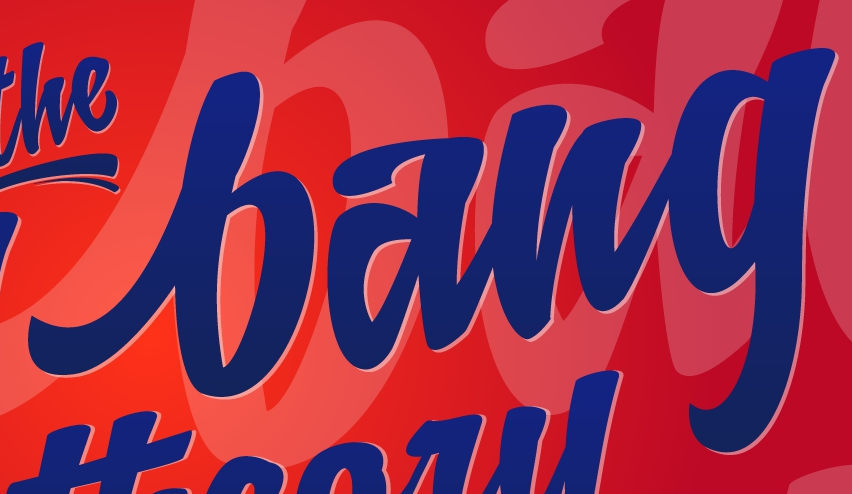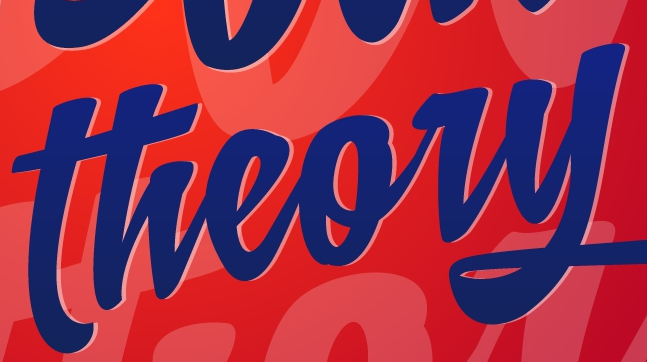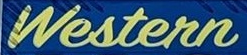What text is displayed in these images sequentially, separated by a semicolon? bang; theory; Western 